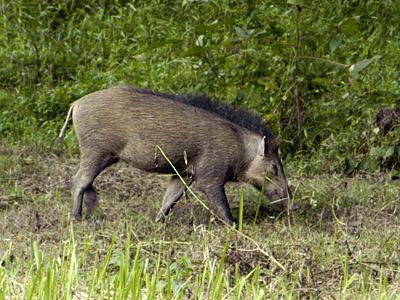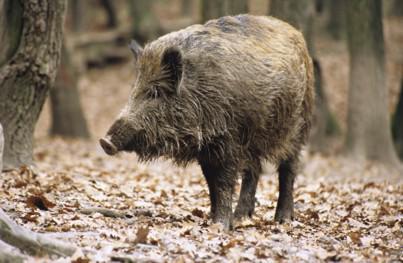The first image is the image on the left, the second image is the image on the right. For the images displayed, is the sentence "Each image contains exactly one wild pig, which is standing up and lacks distinctive stripes." factually correct? Answer yes or no. Yes. The first image is the image on the left, the second image is the image on the right. Examine the images to the left and right. Is the description "Exactly two living beings are in a forest." accurate? Answer yes or no. Yes. 